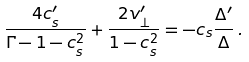Convert formula to latex. <formula><loc_0><loc_0><loc_500><loc_500>\frac { 4 c _ { s } ^ { \prime } } { \Gamma - 1 - c _ { s } ^ { 2 } } + \frac { 2 v _ { \perp } ^ { \prime } } { 1 - c _ { s } ^ { 2 } } = - c _ { s } \frac { \Delta ^ { \prime } } { \Delta } \, .</formula> 